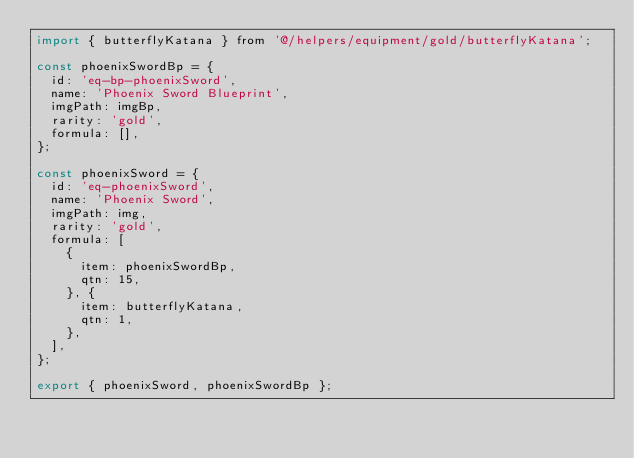Convert code to text. <code><loc_0><loc_0><loc_500><loc_500><_JavaScript_>import { butterflyKatana } from '@/helpers/equipment/gold/butterflyKatana';

const phoenixSwordBp = {
  id: 'eq-bp-phoenixSword',
  name: 'Phoenix Sword Blueprint',
  imgPath: imgBp,
  rarity: 'gold',
  formula: [],
};

const phoenixSword = {
  id: 'eq-phoenixSword',
  name: 'Phoenix Sword',
  imgPath: img,
  rarity: 'gold',
  formula: [
    {
      item: phoenixSwordBp,
      qtn: 15,
    }, {
      item: butterflyKatana,
      qtn: 1,
    },
  ],
};

export { phoenixSword, phoenixSwordBp };
</code> 